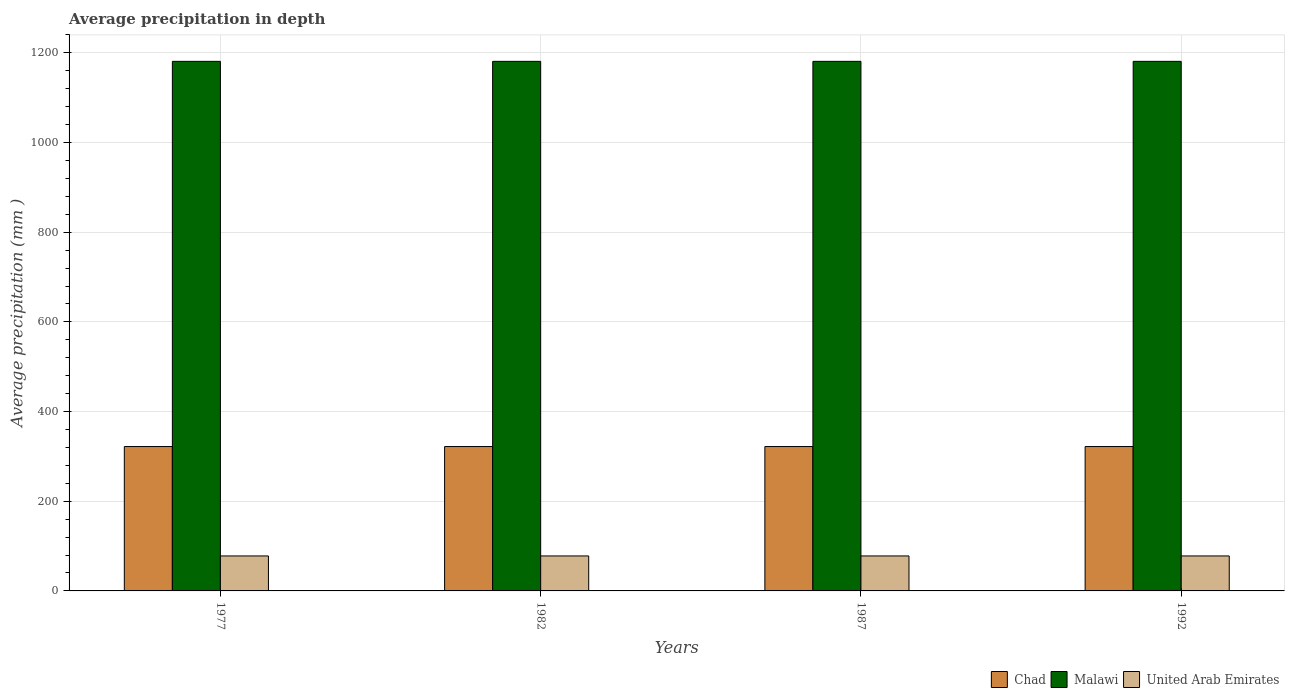How many different coloured bars are there?
Make the answer very short. 3. How many groups of bars are there?
Provide a short and direct response. 4. Are the number of bars per tick equal to the number of legend labels?
Ensure brevity in your answer.  Yes. Are the number of bars on each tick of the X-axis equal?
Your response must be concise. Yes. How many bars are there on the 4th tick from the left?
Keep it short and to the point. 3. In how many cases, is the number of bars for a given year not equal to the number of legend labels?
Offer a very short reply. 0. What is the average precipitation in Chad in 1977?
Offer a terse response. 322. Across all years, what is the maximum average precipitation in United Arab Emirates?
Your response must be concise. 78. Across all years, what is the minimum average precipitation in Malawi?
Your answer should be compact. 1181. In which year was the average precipitation in Malawi maximum?
Your answer should be compact. 1977. In which year was the average precipitation in United Arab Emirates minimum?
Provide a short and direct response. 1977. What is the total average precipitation in Chad in the graph?
Provide a short and direct response. 1288. What is the difference between the average precipitation in Chad in 1992 and the average precipitation in Malawi in 1982?
Make the answer very short. -859. What is the average average precipitation in Malawi per year?
Offer a terse response. 1181. In the year 1977, what is the difference between the average precipitation in Chad and average precipitation in United Arab Emirates?
Your answer should be very brief. 244. In how many years, is the average precipitation in United Arab Emirates greater than 880 mm?
Ensure brevity in your answer.  0. Is the difference between the average precipitation in Chad in 1977 and 1992 greater than the difference between the average precipitation in United Arab Emirates in 1977 and 1992?
Offer a very short reply. No. In how many years, is the average precipitation in Malawi greater than the average average precipitation in Malawi taken over all years?
Keep it short and to the point. 0. Is the sum of the average precipitation in Chad in 1987 and 1992 greater than the maximum average precipitation in United Arab Emirates across all years?
Provide a succinct answer. Yes. What does the 2nd bar from the left in 1992 represents?
Ensure brevity in your answer.  Malawi. What does the 3rd bar from the right in 1992 represents?
Give a very brief answer. Chad. How many bars are there?
Give a very brief answer. 12. How many years are there in the graph?
Provide a short and direct response. 4. What is the difference between two consecutive major ticks on the Y-axis?
Give a very brief answer. 200. Are the values on the major ticks of Y-axis written in scientific E-notation?
Offer a very short reply. No. Does the graph contain any zero values?
Your response must be concise. No. How many legend labels are there?
Ensure brevity in your answer.  3. What is the title of the graph?
Your answer should be very brief. Average precipitation in depth. Does "Sao Tome and Principe" appear as one of the legend labels in the graph?
Your answer should be very brief. No. What is the label or title of the Y-axis?
Make the answer very short. Average precipitation (mm ). What is the Average precipitation (mm ) in Chad in 1977?
Ensure brevity in your answer.  322. What is the Average precipitation (mm ) in Malawi in 1977?
Your answer should be very brief. 1181. What is the Average precipitation (mm ) of United Arab Emirates in 1977?
Offer a very short reply. 78. What is the Average precipitation (mm ) of Chad in 1982?
Provide a succinct answer. 322. What is the Average precipitation (mm ) of Malawi in 1982?
Make the answer very short. 1181. What is the Average precipitation (mm ) in United Arab Emirates in 1982?
Offer a terse response. 78. What is the Average precipitation (mm ) in Chad in 1987?
Ensure brevity in your answer.  322. What is the Average precipitation (mm ) of Malawi in 1987?
Offer a very short reply. 1181. What is the Average precipitation (mm ) in United Arab Emirates in 1987?
Your answer should be very brief. 78. What is the Average precipitation (mm ) of Chad in 1992?
Offer a terse response. 322. What is the Average precipitation (mm ) of Malawi in 1992?
Your response must be concise. 1181. What is the Average precipitation (mm ) of United Arab Emirates in 1992?
Keep it short and to the point. 78. Across all years, what is the maximum Average precipitation (mm ) in Chad?
Make the answer very short. 322. Across all years, what is the maximum Average precipitation (mm ) in Malawi?
Provide a succinct answer. 1181. Across all years, what is the minimum Average precipitation (mm ) of Chad?
Make the answer very short. 322. Across all years, what is the minimum Average precipitation (mm ) in Malawi?
Provide a short and direct response. 1181. What is the total Average precipitation (mm ) in Chad in the graph?
Offer a very short reply. 1288. What is the total Average precipitation (mm ) of Malawi in the graph?
Make the answer very short. 4724. What is the total Average precipitation (mm ) in United Arab Emirates in the graph?
Your answer should be very brief. 312. What is the difference between the Average precipitation (mm ) in United Arab Emirates in 1977 and that in 1982?
Offer a very short reply. 0. What is the difference between the Average precipitation (mm ) of Malawi in 1977 and that in 1987?
Your answer should be compact. 0. What is the difference between the Average precipitation (mm ) of Chad in 1977 and that in 1992?
Offer a terse response. 0. What is the difference between the Average precipitation (mm ) in Malawi in 1977 and that in 1992?
Provide a short and direct response. 0. What is the difference between the Average precipitation (mm ) in United Arab Emirates in 1977 and that in 1992?
Offer a terse response. 0. What is the difference between the Average precipitation (mm ) of Malawi in 1982 and that in 1987?
Make the answer very short. 0. What is the difference between the Average precipitation (mm ) of Malawi in 1982 and that in 1992?
Provide a short and direct response. 0. What is the difference between the Average precipitation (mm ) of Chad in 1987 and that in 1992?
Provide a succinct answer. 0. What is the difference between the Average precipitation (mm ) of Malawi in 1987 and that in 1992?
Make the answer very short. 0. What is the difference between the Average precipitation (mm ) in Chad in 1977 and the Average precipitation (mm ) in Malawi in 1982?
Your response must be concise. -859. What is the difference between the Average precipitation (mm ) of Chad in 1977 and the Average precipitation (mm ) of United Arab Emirates in 1982?
Give a very brief answer. 244. What is the difference between the Average precipitation (mm ) of Malawi in 1977 and the Average precipitation (mm ) of United Arab Emirates in 1982?
Offer a terse response. 1103. What is the difference between the Average precipitation (mm ) in Chad in 1977 and the Average precipitation (mm ) in Malawi in 1987?
Offer a terse response. -859. What is the difference between the Average precipitation (mm ) of Chad in 1977 and the Average precipitation (mm ) of United Arab Emirates in 1987?
Make the answer very short. 244. What is the difference between the Average precipitation (mm ) of Malawi in 1977 and the Average precipitation (mm ) of United Arab Emirates in 1987?
Your answer should be very brief. 1103. What is the difference between the Average precipitation (mm ) of Chad in 1977 and the Average precipitation (mm ) of Malawi in 1992?
Your answer should be very brief. -859. What is the difference between the Average precipitation (mm ) of Chad in 1977 and the Average precipitation (mm ) of United Arab Emirates in 1992?
Provide a short and direct response. 244. What is the difference between the Average precipitation (mm ) of Malawi in 1977 and the Average precipitation (mm ) of United Arab Emirates in 1992?
Offer a very short reply. 1103. What is the difference between the Average precipitation (mm ) in Chad in 1982 and the Average precipitation (mm ) in Malawi in 1987?
Offer a terse response. -859. What is the difference between the Average precipitation (mm ) in Chad in 1982 and the Average precipitation (mm ) in United Arab Emirates in 1987?
Provide a succinct answer. 244. What is the difference between the Average precipitation (mm ) of Malawi in 1982 and the Average precipitation (mm ) of United Arab Emirates in 1987?
Keep it short and to the point. 1103. What is the difference between the Average precipitation (mm ) in Chad in 1982 and the Average precipitation (mm ) in Malawi in 1992?
Your answer should be very brief. -859. What is the difference between the Average precipitation (mm ) in Chad in 1982 and the Average precipitation (mm ) in United Arab Emirates in 1992?
Make the answer very short. 244. What is the difference between the Average precipitation (mm ) in Malawi in 1982 and the Average precipitation (mm ) in United Arab Emirates in 1992?
Keep it short and to the point. 1103. What is the difference between the Average precipitation (mm ) of Chad in 1987 and the Average precipitation (mm ) of Malawi in 1992?
Make the answer very short. -859. What is the difference between the Average precipitation (mm ) in Chad in 1987 and the Average precipitation (mm ) in United Arab Emirates in 1992?
Your answer should be very brief. 244. What is the difference between the Average precipitation (mm ) of Malawi in 1987 and the Average precipitation (mm ) of United Arab Emirates in 1992?
Offer a terse response. 1103. What is the average Average precipitation (mm ) in Chad per year?
Make the answer very short. 322. What is the average Average precipitation (mm ) of Malawi per year?
Give a very brief answer. 1181. What is the average Average precipitation (mm ) of United Arab Emirates per year?
Your response must be concise. 78. In the year 1977, what is the difference between the Average precipitation (mm ) of Chad and Average precipitation (mm ) of Malawi?
Your response must be concise. -859. In the year 1977, what is the difference between the Average precipitation (mm ) in Chad and Average precipitation (mm ) in United Arab Emirates?
Give a very brief answer. 244. In the year 1977, what is the difference between the Average precipitation (mm ) of Malawi and Average precipitation (mm ) of United Arab Emirates?
Offer a very short reply. 1103. In the year 1982, what is the difference between the Average precipitation (mm ) in Chad and Average precipitation (mm ) in Malawi?
Ensure brevity in your answer.  -859. In the year 1982, what is the difference between the Average precipitation (mm ) of Chad and Average precipitation (mm ) of United Arab Emirates?
Keep it short and to the point. 244. In the year 1982, what is the difference between the Average precipitation (mm ) in Malawi and Average precipitation (mm ) in United Arab Emirates?
Ensure brevity in your answer.  1103. In the year 1987, what is the difference between the Average precipitation (mm ) of Chad and Average precipitation (mm ) of Malawi?
Offer a very short reply. -859. In the year 1987, what is the difference between the Average precipitation (mm ) of Chad and Average precipitation (mm ) of United Arab Emirates?
Provide a succinct answer. 244. In the year 1987, what is the difference between the Average precipitation (mm ) in Malawi and Average precipitation (mm ) in United Arab Emirates?
Ensure brevity in your answer.  1103. In the year 1992, what is the difference between the Average precipitation (mm ) of Chad and Average precipitation (mm ) of Malawi?
Give a very brief answer. -859. In the year 1992, what is the difference between the Average precipitation (mm ) in Chad and Average precipitation (mm ) in United Arab Emirates?
Provide a succinct answer. 244. In the year 1992, what is the difference between the Average precipitation (mm ) of Malawi and Average precipitation (mm ) of United Arab Emirates?
Your answer should be very brief. 1103. What is the ratio of the Average precipitation (mm ) in United Arab Emirates in 1977 to that in 1982?
Provide a succinct answer. 1. What is the ratio of the Average precipitation (mm ) in Chad in 1977 to that in 1987?
Offer a terse response. 1. What is the ratio of the Average precipitation (mm ) of Malawi in 1977 to that in 1992?
Keep it short and to the point. 1. What is the ratio of the Average precipitation (mm ) of Chad in 1982 to that in 1987?
Make the answer very short. 1. What is the ratio of the Average precipitation (mm ) in Chad in 1982 to that in 1992?
Give a very brief answer. 1. What is the ratio of the Average precipitation (mm ) in Malawi in 1987 to that in 1992?
Make the answer very short. 1. What is the ratio of the Average precipitation (mm ) in United Arab Emirates in 1987 to that in 1992?
Make the answer very short. 1. What is the difference between the highest and the second highest Average precipitation (mm ) in Chad?
Your answer should be compact. 0. What is the difference between the highest and the lowest Average precipitation (mm ) of Chad?
Your answer should be very brief. 0. What is the difference between the highest and the lowest Average precipitation (mm ) of Malawi?
Your response must be concise. 0. What is the difference between the highest and the lowest Average precipitation (mm ) in United Arab Emirates?
Your response must be concise. 0. 